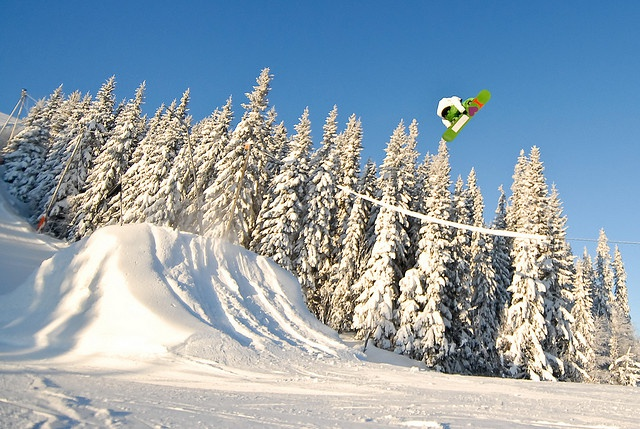Describe the objects in this image and their specific colors. I can see snowboard in teal, olive, ivory, green, and purple tones and people in teal, ivory, black, beige, and darkgray tones in this image. 